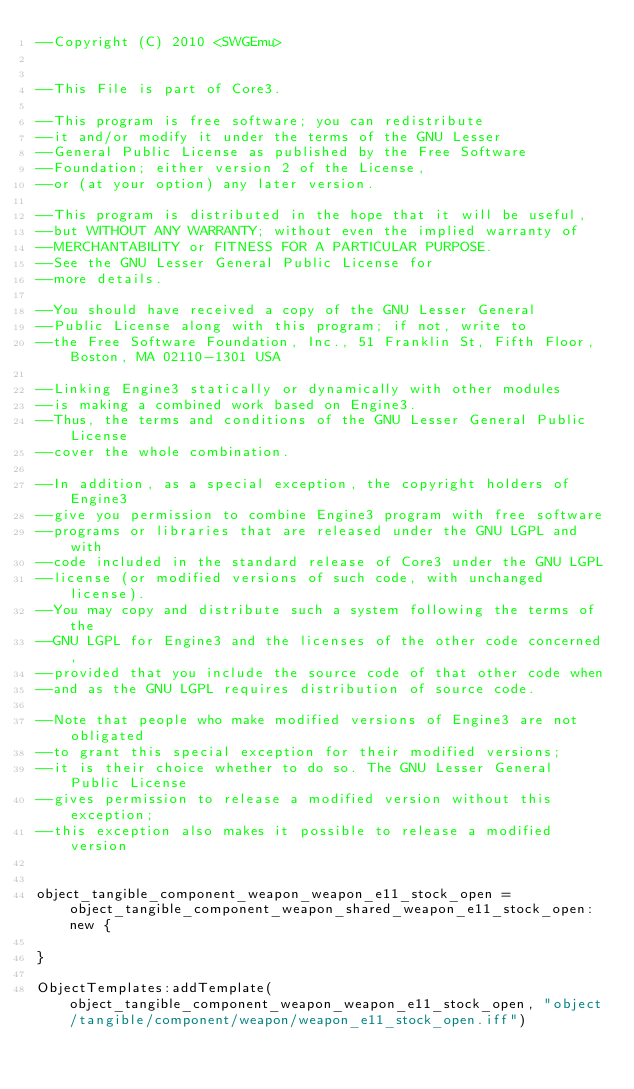Convert code to text. <code><loc_0><loc_0><loc_500><loc_500><_Lua_>--Copyright (C) 2010 <SWGEmu>


--This File is part of Core3.

--This program is free software; you can redistribute 
--it and/or modify it under the terms of the GNU Lesser 
--General Public License as published by the Free Software
--Foundation; either version 2 of the License, 
--or (at your option) any later version.

--This program is distributed in the hope that it will be useful, 
--but WITHOUT ANY WARRANTY; without even the implied warranty of 
--MERCHANTABILITY or FITNESS FOR A PARTICULAR PURPOSE. 
--See the GNU Lesser General Public License for
--more details.

--You should have received a copy of the GNU Lesser General 
--Public License along with this program; if not, write to
--the Free Software Foundation, Inc., 51 Franklin St, Fifth Floor, Boston, MA 02110-1301 USA

--Linking Engine3 statically or dynamically with other modules 
--is making a combined work based on Engine3. 
--Thus, the terms and conditions of the GNU Lesser General Public License 
--cover the whole combination.

--In addition, as a special exception, the copyright holders of Engine3 
--give you permission to combine Engine3 program with free software 
--programs or libraries that are released under the GNU LGPL and with 
--code included in the standard release of Core3 under the GNU LGPL 
--license (or modified versions of such code, with unchanged license). 
--You may copy and distribute such a system following the terms of the 
--GNU LGPL for Engine3 and the licenses of the other code concerned, 
--provided that you include the source code of that other code when 
--and as the GNU LGPL requires distribution of source code.

--Note that people who make modified versions of Engine3 are not obligated 
--to grant this special exception for their modified versions; 
--it is their choice whether to do so. The GNU Lesser General Public License 
--gives permission to release a modified version without this exception; 
--this exception also makes it possible to release a modified version 


object_tangible_component_weapon_weapon_e11_stock_open = object_tangible_component_weapon_shared_weapon_e11_stock_open:new {

}

ObjectTemplates:addTemplate(object_tangible_component_weapon_weapon_e11_stock_open, "object/tangible/component/weapon/weapon_e11_stock_open.iff")
</code> 